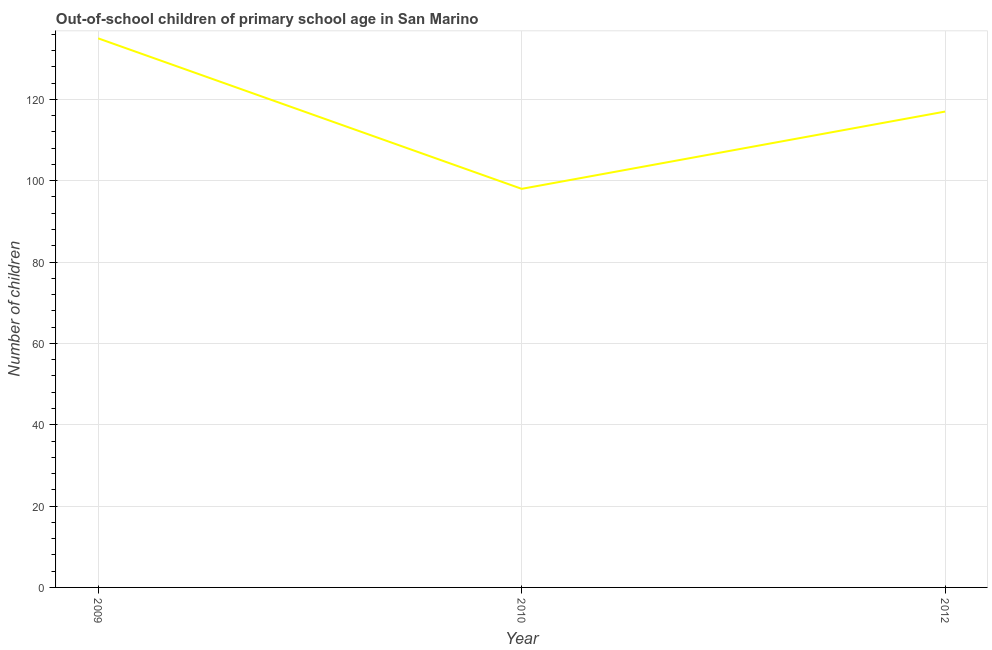What is the number of out-of-school children in 2010?
Your answer should be compact. 98. Across all years, what is the maximum number of out-of-school children?
Keep it short and to the point. 135. Across all years, what is the minimum number of out-of-school children?
Provide a succinct answer. 98. In which year was the number of out-of-school children minimum?
Provide a succinct answer. 2010. What is the sum of the number of out-of-school children?
Offer a very short reply. 350. What is the difference between the number of out-of-school children in 2010 and 2012?
Provide a succinct answer. -19. What is the average number of out-of-school children per year?
Provide a succinct answer. 116.67. What is the median number of out-of-school children?
Give a very brief answer. 117. In how many years, is the number of out-of-school children greater than 88 ?
Your response must be concise. 3. Do a majority of the years between 2010 and 2012 (inclusive) have number of out-of-school children greater than 40 ?
Offer a terse response. Yes. What is the ratio of the number of out-of-school children in 2010 to that in 2012?
Your answer should be very brief. 0.84. Is the number of out-of-school children in 2010 less than that in 2012?
Your response must be concise. Yes. Is the difference between the number of out-of-school children in 2009 and 2012 greater than the difference between any two years?
Provide a succinct answer. No. What is the difference between the highest and the second highest number of out-of-school children?
Offer a terse response. 18. Is the sum of the number of out-of-school children in 2010 and 2012 greater than the maximum number of out-of-school children across all years?
Provide a succinct answer. Yes. What is the difference between the highest and the lowest number of out-of-school children?
Provide a short and direct response. 37. In how many years, is the number of out-of-school children greater than the average number of out-of-school children taken over all years?
Provide a short and direct response. 2. Does the number of out-of-school children monotonically increase over the years?
Give a very brief answer. No. How many lines are there?
Offer a very short reply. 1. How many years are there in the graph?
Provide a short and direct response. 3. What is the difference between two consecutive major ticks on the Y-axis?
Your answer should be compact. 20. Are the values on the major ticks of Y-axis written in scientific E-notation?
Give a very brief answer. No. What is the title of the graph?
Provide a succinct answer. Out-of-school children of primary school age in San Marino. What is the label or title of the Y-axis?
Make the answer very short. Number of children. What is the Number of children in 2009?
Give a very brief answer. 135. What is the Number of children in 2010?
Ensure brevity in your answer.  98. What is the Number of children of 2012?
Provide a short and direct response. 117. What is the difference between the Number of children in 2009 and 2010?
Ensure brevity in your answer.  37. What is the ratio of the Number of children in 2009 to that in 2010?
Provide a succinct answer. 1.38. What is the ratio of the Number of children in 2009 to that in 2012?
Your response must be concise. 1.15. What is the ratio of the Number of children in 2010 to that in 2012?
Make the answer very short. 0.84. 